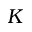<formula> <loc_0><loc_0><loc_500><loc_500>K</formula> 